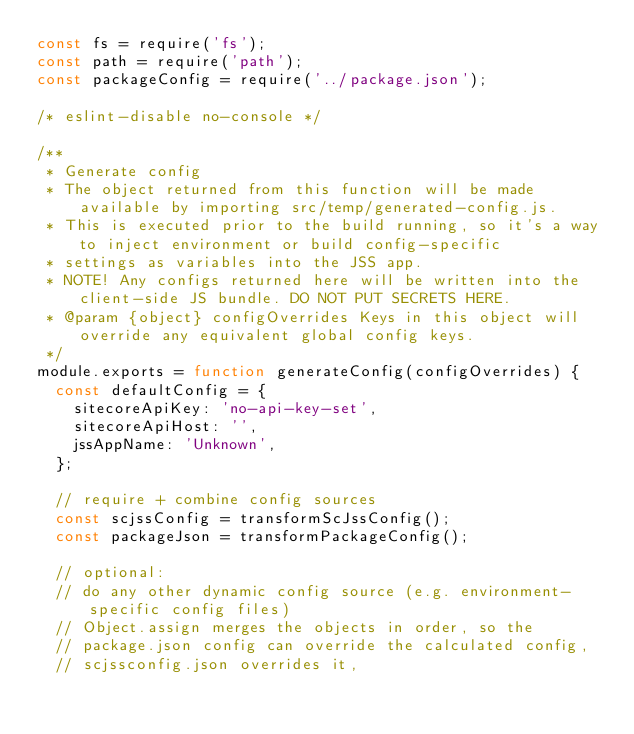Convert code to text. <code><loc_0><loc_0><loc_500><loc_500><_JavaScript_>const fs = require('fs');
const path = require('path');
const packageConfig = require('../package.json');

/* eslint-disable no-console */

/**
 * Generate config
 * The object returned from this function will be made available by importing src/temp/generated-config.js.
 * This is executed prior to the build running, so it's a way to inject environment or build config-specific
 * settings as variables into the JSS app.
 * NOTE! Any configs returned here will be written into the client-side JS bundle. DO NOT PUT SECRETS HERE.
 * @param {object} configOverrides Keys in this object will override any equivalent global config keys.
 */
module.exports = function generateConfig(configOverrides) {
  const defaultConfig = {
    sitecoreApiKey: 'no-api-key-set',
    sitecoreApiHost: '',
    jssAppName: 'Unknown',
  };

  // require + combine config sources
  const scjssConfig = transformScJssConfig();
  const packageJson = transformPackageConfig();

  // optional:
  // do any other dynamic config source (e.g. environment-specific config files)
  // Object.assign merges the objects in order, so the
  // package.json config can override the calculated config,
  // scjssconfig.json overrides it,</code> 